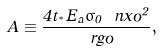<formula> <loc_0><loc_0><loc_500><loc_500>A \equiv \frac { 4 t _ { ^ { * } } E _ { a } \sigma _ { 0 } \ n x o ^ { 2 } } { \ r g o } ,</formula> 